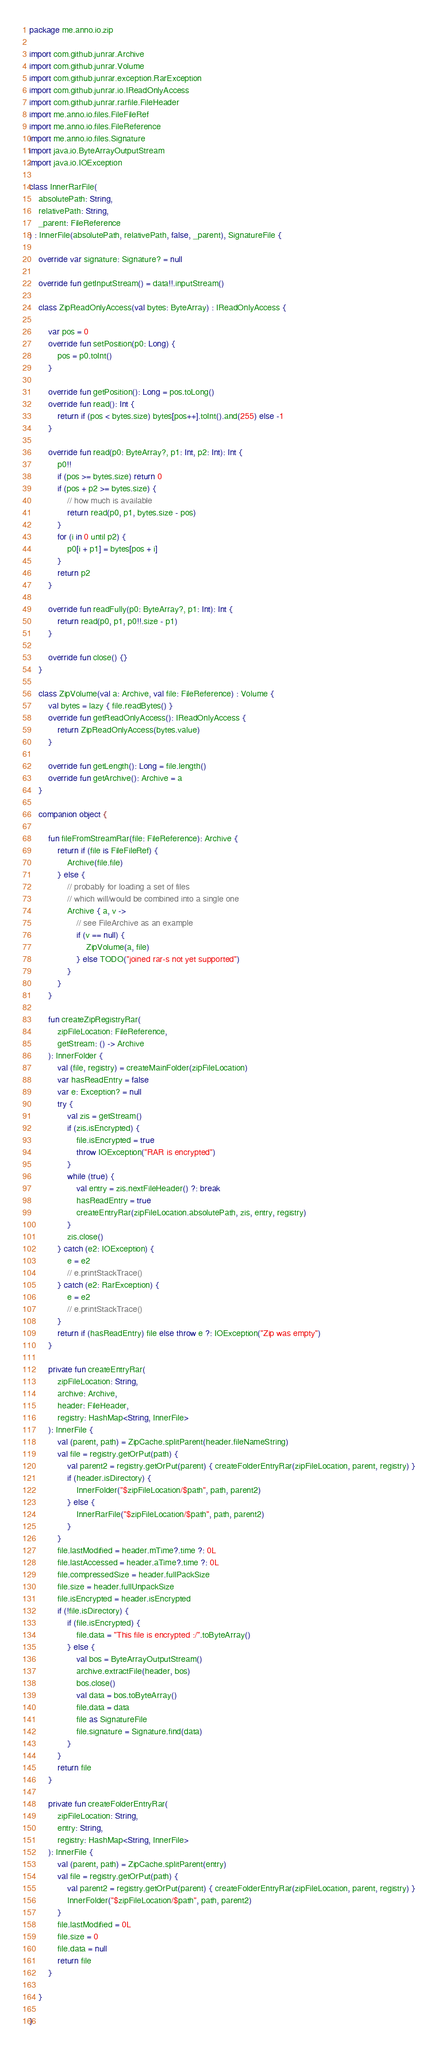<code> <loc_0><loc_0><loc_500><loc_500><_Kotlin_>package me.anno.io.zip

import com.github.junrar.Archive
import com.github.junrar.Volume
import com.github.junrar.exception.RarException
import com.github.junrar.io.IReadOnlyAccess
import com.github.junrar.rarfile.FileHeader
import me.anno.io.files.FileFileRef
import me.anno.io.files.FileReference
import me.anno.io.files.Signature
import java.io.ByteArrayOutputStream
import java.io.IOException

class InnerRarFile(
    absolutePath: String,
    relativePath: String,
    _parent: FileReference
) : InnerFile(absolutePath, relativePath, false, _parent), SignatureFile {

    override var signature: Signature? = null

    override fun getInputStream() = data!!.inputStream()

    class ZipReadOnlyAccess(val bytes: ByteArray) : IReadOnlyAccess {

        var pos = 0
        override fun setPosition(p0: Long) {
            pos = p0.toInt()
        }

        override fun getPosition(): Long = pos.toLong()
        override fun read(): Int {
            return if (pos < bytes.size) bytes[pos++].toInt().and(255) else -1
        }

        override fun read(p0: ByteArray?, p1: Int, p2: Int): Int {
            p0!!
            if (pos >= bytes.size) return 0
            if (pos + p2 >= bytes.size) {
                // how much is available
                return read(p0, p1, bytes.size - pos)
            }
            for (i in 0 until p2) {
                p0[i + p1] = bytes[pos + i]
            }
            return p2
        }

        override fun readFully(p0: ByteArray?, p1: Int): Int {
            return read(p0, p1, p0!!.size - p1)
        }

        override fun close() {}
    }

    class ZipVolume(val a: Archive, val file: FileReference) : Volume {
        val bytes = lazy { file.readBytes() }
        override fun getReadOnlyAccess(): IReadOnlyAccess {
            return ZipReadOnlyAccess(bytes.value)
        }

        override fun getLength(): Long = file.length()
        override fun getArchive(): Archive = a
    }

    companion object {

        fun fileFromStreamRar(file: FileReference): Archive {
            return if (file is FileFileRef) {
                Archive(file.file)
            } else {
                // probably for loading a set of files
                // which will/would be combined into a single one
                Archive { a, v ->
                    // see FileArchive as an example
                    if (v == null) {
                        ZipVolume(a, file)
                    } else TODO("joined rar-s not yet supported")
                }
            }
        }

        fun createZipRegistryRar(
            zipFileLocation: FileReference,
            getStream: () -> Archive
        ): InnerFolder {
            val (file, registry) = createMainFolder(zipFileLocation)
            var hasReadEntry = false
            var e: Exception? = null
            try {
                val zis = getStream()
                if (zis.isEncrypted) {
                    file.isEncrypted = true
                    throw IOException("RAR is encrypted")
                }
                while (true) {
                    val entry = zis.nextFileHeader() ?: break
                    hasReadEntry = true
                    createEntryRar(zipFileLocation.absolutePath, zis, entry, registry)
                }
                zis.close()
            } catch (e2: IOException) {
                e = e2
                // e.printStackTrace()
            } catch (e2: RarException) {
                e = e2
                // e.printStackTrace()
            }
            return if (hasReadEntry) file else throw e ?: IOException("Zip was empty")
        }

        private fun createEntryRar(
            zipFileLocation: String,
            archive: Archive,
            header: FileHeader,
            registry: HashMap<String, InnerFile>
        ): InnerFile {
            val (parent, path) = ZipCache.splitParent(header.fileNameString)
            val file = registry.getOrPut(path) {
                val parent2 = registry.getOrPut(parent) { createFolderEntryRar(zipFileLocation, parent, registry) }
                if (header.isDirectory) {
                    InnerFolder("$zipFileLocation/$path", path, parent2)
                } else {
                    InnerRarFile("$zipFileLocation/$path", path, parent2)
                }
            }
            file.lastModified = header.mTime?.time ?: 0L
            file.lastAccessed = header.aTime?.time ?: 0L
            file.compressedSize = header.fullPackSize
            file.size = header.fullUnpackSize
            file.isEncrypted = header.isEncrypted
            if (!file.isDirectory) {
                if (file.isEncrypted) {
                    file.data = "This file is encrypted :/".toByteArray()
                } else {
                    val bos = ByteArrayOutputStream()
                    archive.extractFile(header, bos)
                    bos.close()
                    val data = bos.toByteArray()
                    file.data = data
                    file as SignatureFile
                    file.signature = Signature.find(data)
                }
            }
            return file
        }

        private fun createFolderEntryRar(
            zipFileLocation: String,
            entry: String,
            registry: HashMap<String, InnerFile>
        ): InnerFile {
            val (parent, path) = ZipCache.splitParent(entry)
            val file = registry.getOrPut(path) {
                val parent2 = registry.getOrPut(parent) { createFolderEntryRar(zipFileLocation, parent, registry) }
                InnerFolder("$zipFileLocation/$path", path, parent2)
            }
            file.lastModified = 0L
            file.size = 0
            file.data = null
            return file
        }

    }

}</code> 